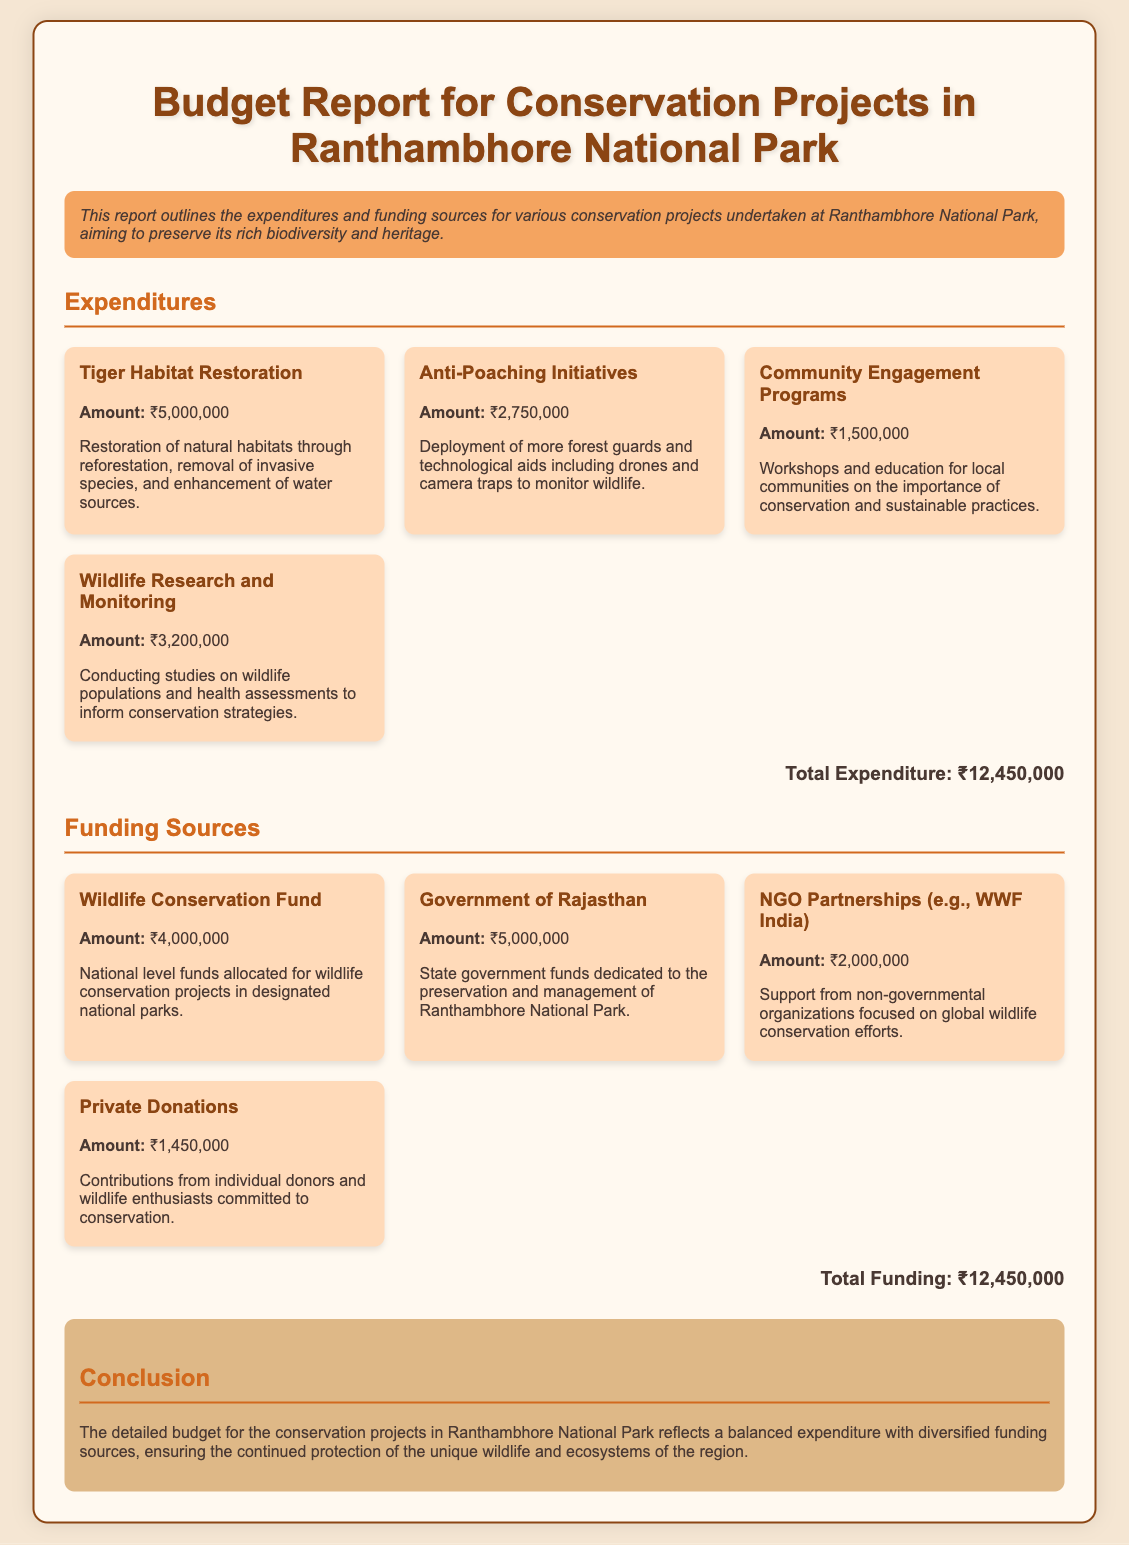What is the total expenditure for conservation projects? The total expenditure is calculated by adding all the individual expenditures listed in the document, which totals ₹12,450,000.
Answer: ₹12,450,000 What is the funding amount from the Government of Rajasthan? The document specifies that the Government of Rajasthan provided ₹5,000,000 for the conservation projects.
Answer: ₹5,000,000 How much was spent on Anti-Poaching Initiatives? The expenditure specifically allocated for Anti-Poaching Initiatives amounts to ₹2,750,000 as mentioned in the report.
Answer: ₹2,750,000 What is the main purpose of Community Engagement Programs? The report indicates that the purpose of Community Engagement Programs is to educate local communities about conservation and sustainable practices.
Answer: Education on conservation Which organization is mentioned as a partner NGO? The document highlights WWF India as an example of a partnering NGO involved in the conservation efforts at Ranthambhore National Park.
Answer: WWF India How much funding was received from Private Donations? According to the report, Private Donations contributed a total of ₹1,450,000 to the conservation projects.
Answer: ₹1,450,000 What is the total funding received for the conservation projects? The total funding listed in the document is the same as total expenditure which totals ₹12,450,000.
Answer: ₹12,450,000 What is the focus of Wildlife Research and Monitoring? The focus of Wildlife Research and Monitoring, as outlined in the report, is to conduct studies on wildlife populations and health assessments.
Answer: Studies on wildlife populations How does the report categorize its budget information? The report categorizes its budget information into two main sections: Expenditures and Funding Sources.
Answer: Expenditures and Funding Sources 